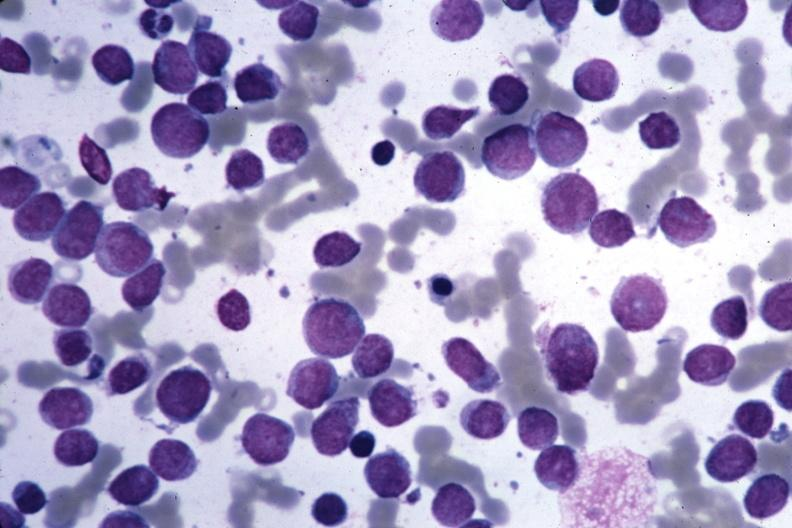what is wrights seen?
Answer the question using a single word or phrase. Blastic cells 